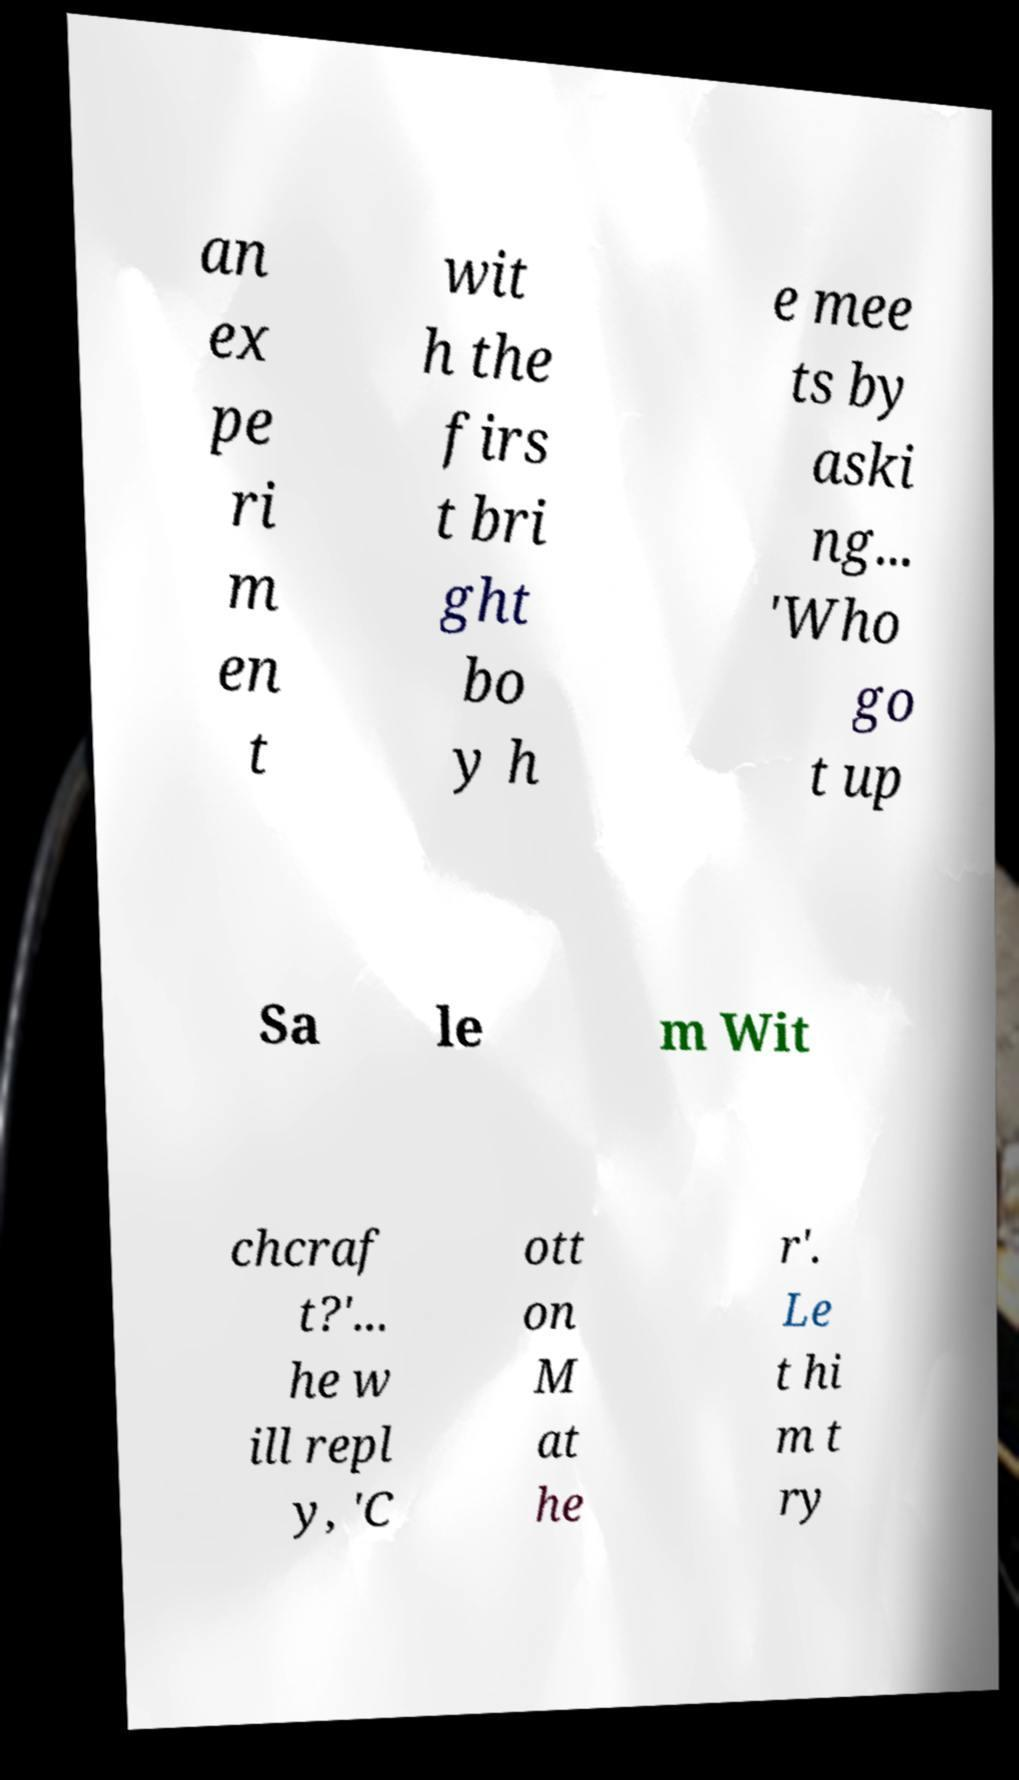Could you extract and type out the text from this image? an ex pe ri m en t wit h the firs t bri ght bo y h e mee ts by aski ng... 'Who go t up Sa le m Wit chcraf t?'... he w ill repl y, 'C ott on M at he r'. Le t hi m t ry 